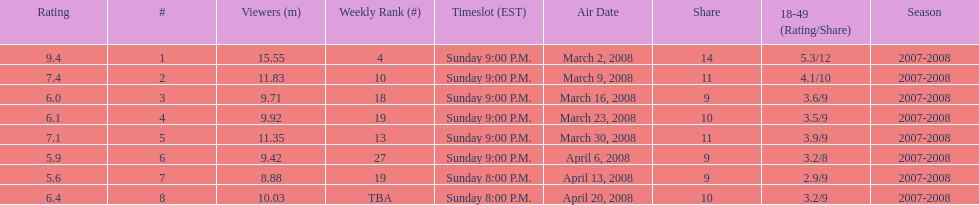Did the season finish at an earlier or later timeslot? Earlier. 